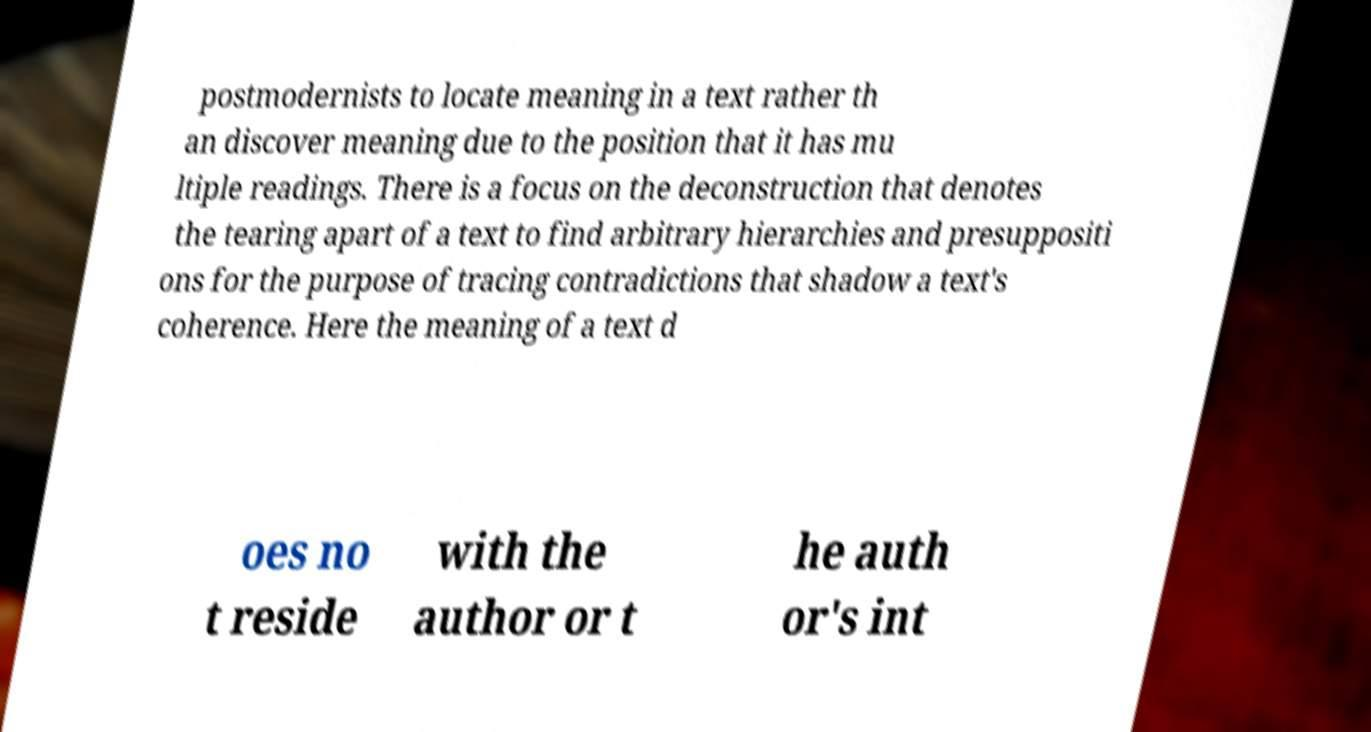Could you assist in decoding the text presented in this image and type it out clearly? postmodernists to locate meaning in a text rather th an discover meaning due to the position that it has mu ltiple readings. There is a focus on the deconstruction that denotes the tearing apart of a text to find arbitrary hierarchies and presuppositi ons for the purpose of tracing contradictions that shadow a text's coherence. Here the meaning of a text d oes no t reside with the author or t he auth or's int 